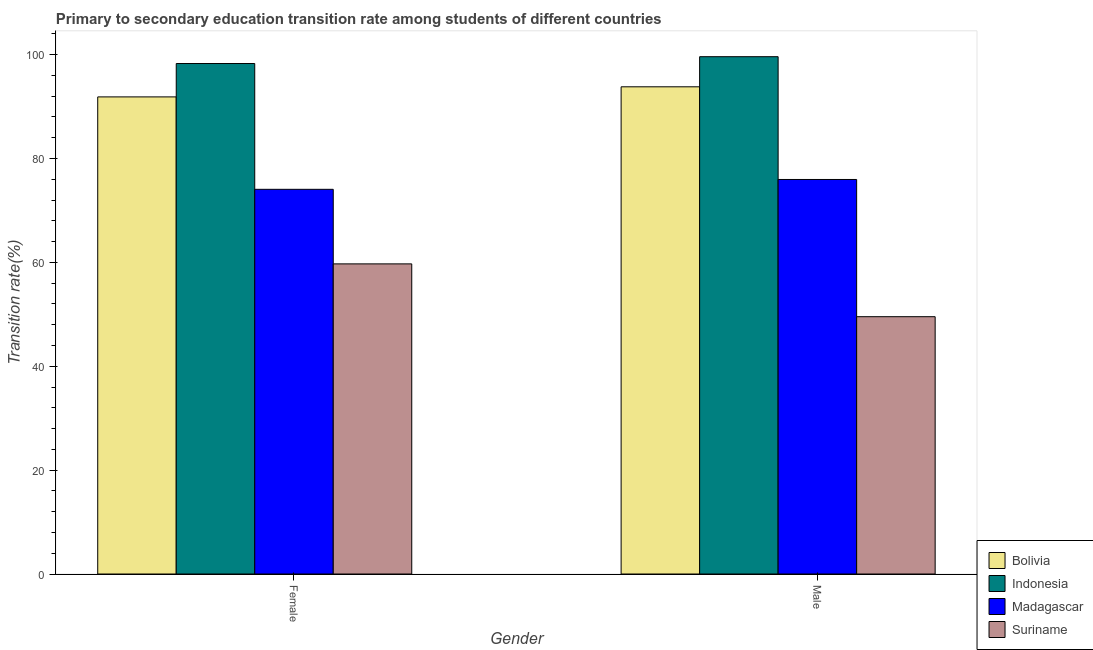Are the number of bars per tick equal to the number of legend labels?
Make the answer very short. Yes. How many bars are there on the 1st tick from the left?
Offer a terse response. 4. How many bars are there on the 1st tick from the right?
Your answer should be compact. 4. What is the label of the 2nd group of bars from the left?
Your answer should be very brief. Male. What is the transition rate among female students in Suriname?
Your answer should be very brief. 59.7. Across all countries, what is the maximum transition rate among male students?
Your answer should be compact. 99.59. Across all countries, what is the minimum transition rate among male students?
Provide a succinct answer. 49.53. In which country was the transition rate among male students minimum?
Offer a terse response. Suriname. What is the total transition rate among female students in the graph?
Offer a terse response. 323.88. What is the difference between the transition rate among female students in Madagascar and that in Suriname?
Provide a short and direct response. 14.35. What is the difference between the transition rate among male students in Indonesia and the transition rate among female students in Suriname?
Keep it short and to the point. 39.89. What is the average transition rate among male students per country?
Ensure brevity in your answer.  79.72. What is the difference between the transition rate among male students and transition rate among female students in Bolivia?
Make the answer very short. 1.95. In how many countries, is the transition rate among female students greater than 44 %?
Your answer should be compact. 4. What is the ratio of the transition rate among female students in Suriname to that in Indonesia?
Provide a succinct answer. 0.61. Is the transition rate among male students in Suriname less than that in Madagascar?
Make the answer very short. Yes. What does the 3rd bar from the left in Female represents?
Your answer should be very brief. Madagascar. What does the 1st bar from the right in Male represents?
Offer a very short reply. Suriname. Are all the bars in the graph horizontal?
Your answer should be compact. No. How many countries are there in the graph?
Your answer should be very brief. 4. What is the difference between two consecutive major ticks on the Y-axis?
Your answer should be compact. 20. Are the values on the major ticks of Y-axis written in scientific E-notation?
Make the answer very short. No. Does the graph contain any zero values?
Your answer should be very brief. No. Does the graph contain grids?
Provide a succinct answer. No. How many legend labels are there?
Your response must be concise. 4. What is the title of the graph?
Provide a short and direct response. Primary to secondary education transition rate among students of different countries. Does "Hungary" appear as one of the legend labels in the graph?
Your answer should be very brief. No. What is the label or title of the Y-axis?
Make the answer very short. Transition rate(%). What is the Transition rate(%) of Bolivia in Female?
Keep it short and to the point. 91.85. What is the Transition rate(%) in Indonesia in Female?
Give a very brief answer. 98.28. What is the Transition rate(%) in Madagascar in Female?
Offer a very short reply. 74.06. What is the Transition rate(%) of Suriname in Female?
Ensure brevity in your answer.  59.7. What is the Transition rate(%) in Bolivia in Male?
Ensure brevity in your answer.  93.79. What is the Transition rate(%) of Indonesia in Male?
Your answer should be compact. 99.59. What is the Transition rate(%) in Madagascar in Male?
Your response must be concise. 75.95. What is the Transition rate(%) in Suriname in Male?
Keep it short and to the point. 49.53. Across all Gender, what is the maximum Transition rate(%) of Bolivia?
Offer a terse response. 93.79. Across all Gender, what is the maximum Transition rate(%) in Indonesia?
Give a very brief answer. 99.59. Across all Gender, what is the maximum Transition rate(%) of Madagascar?
Your answer should be very brief. 75.95. Across all Gender, what is the maximum Transition rate(%) of Suriname?
Provide a short and direct response. 59.7. Across all Gender, what is the minimum Transition rate(%) in Bolivia?
Offer a terse response. 91.85. Across all Gender, what is the minimum Transition rate(%) in Indonesia?
Provide a short and direct response. 98.28. Across all Gender, what is the minimum Transition rate(%) of Madagascar?
Offer a terse response. 74.06. Across all Gender, what is the minimum Transition rate(%) of Suriname?
Offer a very short reply. 49.53. What is the total Transition rate(%) of Bolivia in the graph?
Offer a terse response. 185.64. What is the total Transition rate(%) in Indonesia in the graph?
Your response must be concise. 197.87. What is the total Transition rate(%) of Madagascar in the graph?
Provide a succinct answer. 150.01. What is the total Transition rate(%) of Suriname in the graph?
Offer a terse response. 109.24. What is the difference between the Transition rate(%) in Bolivia in Female and that in Male?
Your answer should be very brief. -1.95. What is the difference between the Transition rate(%) in Indonesia in Female and that in Male?
Offer a terse response. -1.31. What is the difference between the Transition rate(%) in Madagascar in Female and that in Male?
Keep it short and to the point. -1.9. What is the difference between the Transition rate(%) of Suriname in Female and that in Male?
Make the answer very short. 10.17. What is the difference between the Transition rate(%) of Bolivia in Female and the Transition rate(%) of Indonesia in Male?
Ensure brevity in your answer.  -7.74. What is the difference between the Transition rate(%) of Bolivia in Female and the Transition rate(%) of Madagascar in Male?
Provide a succinct answer. 15.9. What is the difference between the Transition rate(%) in Bolivia in Female and the Transition rate(%) in Suriname in Male?
Make the answer very short. 42.31. What is the difference between the Transition rate(%) of Indonesia in Female and the Transition rate(%) of Madagascar in Male?
Ensure brevity in your answer.  22.32. What is the difference between the Transition rate(%) in Indonesia in Female and the Transition rate(%) in Suriname in Male?
Ensure brevity in your answer.  48.74. What is the difference between the Transition rate(%) of Madagascar in Female and the Transition rate(%) of Suriname in Male?
Give a very brief answer. 24.52. What is the average Transition rate(%) of Bolivia per Gender?
Your response must be concise. 92.82. What is the average Transition rate(%) in Indonesia per Gender?
Ensure brevity in your answer.  98.93. What is the average Transition rate(%) of Madagascar per Gender?
Ensure brevity in your answer.  75. What is the average Transition rate(%) in Suriname per Gender?
Your answer should be compact. 54.62. What is the difference between the Transition rate(%) of Bolivia and Transition rate(%) of Indonesia in Female?
Give a very brief answer. -6.43. What is the difference between the Transition rate(%) of Bolivia and Transition rate(%) of Madagascar in Female?
Your answer should be very brief. 17.79. What is the difference between the Transition rate(%) in Bolivia and Transition rate(%) in Suriname in Female?
Your answer should be compact. 32.15. What is the difference between the Transition rate(%) in Indonesia and Transition rate(%) in Madagascar in Female?
Make the answer very short. 24.22. What is the difference between the Transition rate(%) of Indonesia and Transition rate(%) of Suriname in Female?
Offer a very short reply. 38.57. What is the difference between the Transition rate(%) of Madagascar and Transition rate(%) of Suriname in Female?
Ensure brevity in your answer.  14.35. What is the difference between the Transition rate(%) of Bolivia and Transition rate(%) of Indonesia in Male?
Ensure brevity in your answer.  -5.8. What is the difference between the Transition rate(%) of Bolivia and Transition rate(%) of Madagascar in Male?
Your answer should be very brief. 17.84. What is the difference between the Transition rate(%) of Bolivia and Transition rate(%) of Suriname in Male?
Keep it short and to the point. 44.26. What is the difference between the Transition rate(%) of Indonesia and Transition rate(%) of Madagascar in Male?
Your answer should be very brief. 23.64. What is the difference between the Transition rate(%) in Indonesia and Transition rate(%) in Suriname in Male?
Offer a terse response. 50.06. What is the difference between the Transition rate(%) in Madagascar and Transition rate(%) in Suriname in Male?
Your answer should be compact. 26.42. What is the ratio of the Transition rate(%) of Bolivia in Female to that in Male?
Make the answer very short. 0.98. What is the ratio of the Transition rate(%) of Madagascar in Female to that in Male?
Make the answer very short. 0.97. What is the ratio of the Transition rate(%) in Suriname in Female to that in Male?
Your answer should be very brief. 1.21. What is the difference between the highest and the second highest Transition rate(%) in Bolivia?
Make the answer very short. 1.95. What is the difference between the highest and the second highest Transition rate(%) in Indonesia?
Offer a very short reply. 1.31. What is the difference between the highest and the second highest Transition rate(%) of Madagascar?
Give a very brief answer. 1.9. What is the difference between the highest and the second highest Transition rate(%) in Suriname?
Your answer should be very brief. 10.17. What is the difference between the highest and the lowest Transition rate(%) of Bolivia?
Offer a terse response. 1.95. What is the difference between the highest and the lowest Transition rate(%) of Indonesia?
Your answer should be compact. 1.31. What is the difference between the highest and the lowest Transition rate(%) of Madagascar?
Offer a terse response. 1.9. What is the difference between the highest and the lowest Transition rate(%) of Suriname?
Make the answer very short. 10.17. 